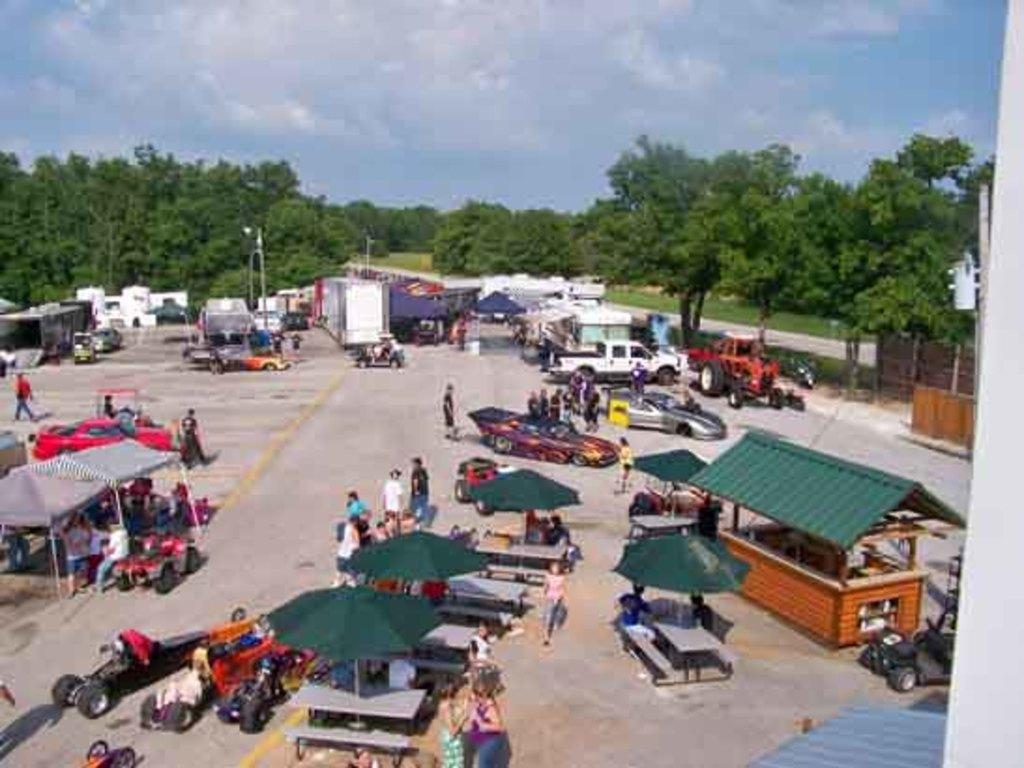In one or two sentences, can you explain what this image depicts? In this image there are tents, cars, buildings on the road and we can see people are walking on the road. In the background there are trees and sky. At the bottom there is grass on the surface. 